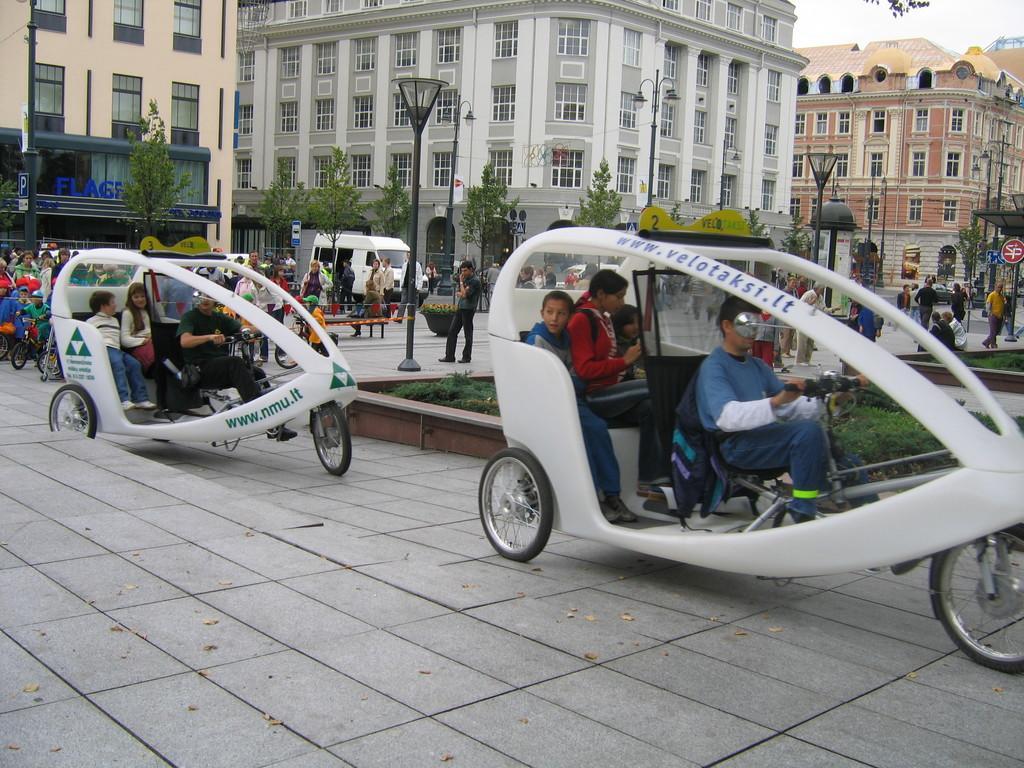How would you summarize this image in a sentence or two? In this image we can see some people sitting in the vehicles. We can also see a group of people on the ground, some children riding bicycles, street poles, signboards, trees, some plants, buildings with windows and the sky. 